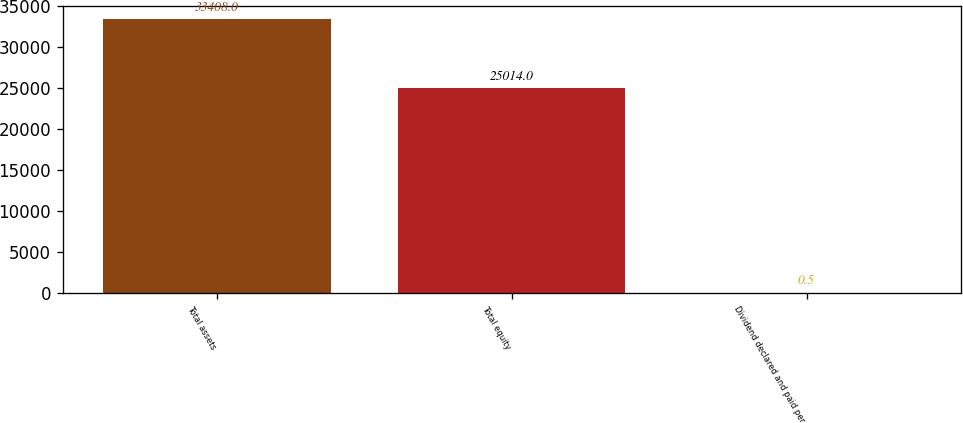<chart> <loc_0><loc_0><loc_500><loc_500><bar_chart><fcel>Total assets<fcel>Total equity<fcel>Dividend declared and paid per<nl><fcel>33408<fcel>25014<fcel>0.5<nl></chart> 